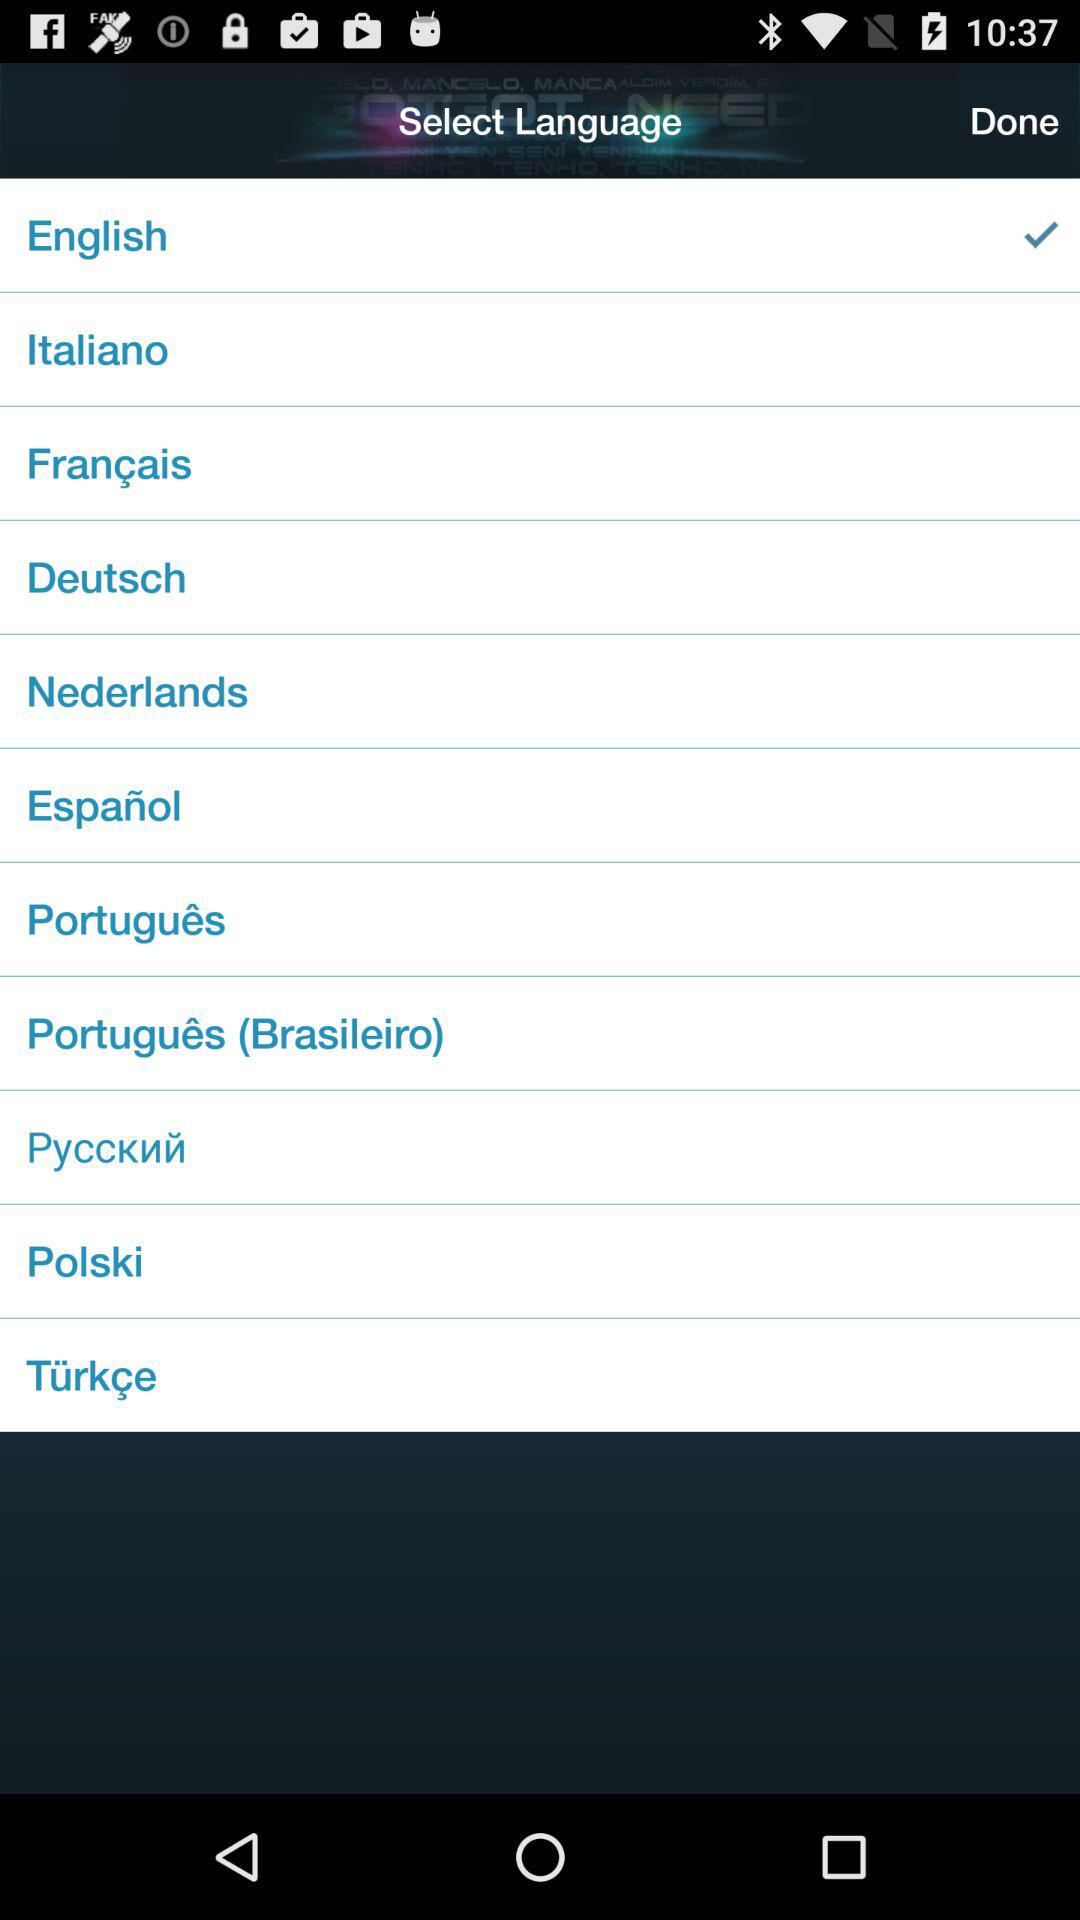What is the name of the user?
When the provided information is insufficient, respond with <no answer>. <no answer> 